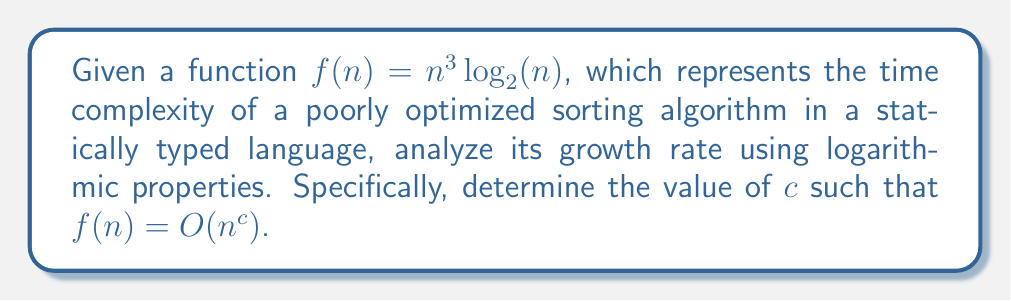Teach me how to tackle this problem. Let's approach this step-by-step:

1) We start with $f(n) = n^3 \log_2(n)$

2) To find $c$, we need to express $f(n)$ in the form $n^c$. This means we need to incorporate the logarithmic term into the exponent.

3) Using the logarithmic property $\log_a(x^y) = y\log_a(x)$, we can rewrite $f(n)$ as:

   $f(n) = n^3 \log_2(n) = 2^{\log_2(n^3 \log_2(n))}$

4) Now, let's focus on the exponent:

   $\log_2(n^3 \log_2(n)) = \log_2(n^3) + \log_2(\log_2(n))$

5) Using the property $\log_a(x^y) = y\log_a(x)$ again:

   $\log_2(n^3) + \log_2(\log_2(n)) = 3\log_2(n) + \log_2(\log_2(n))$

6) As $n$ grows, $\log_2(\log_2(n))$ grows much slower than $\log_2(n)$. For large $n$, we can approximate:

   $3\log_2(n) + \log_2(\log_2(n)) \approx 3\log_2(n)$

7) Therefore, for large $n$:

   $f(n) \approx 2^{3\log_2(n)} = (2^{\log_2(n)})^3 = n^3$

8) Thus, we can conclude that $f(n) = O(n^3)$
Answer: $c = 3$ 